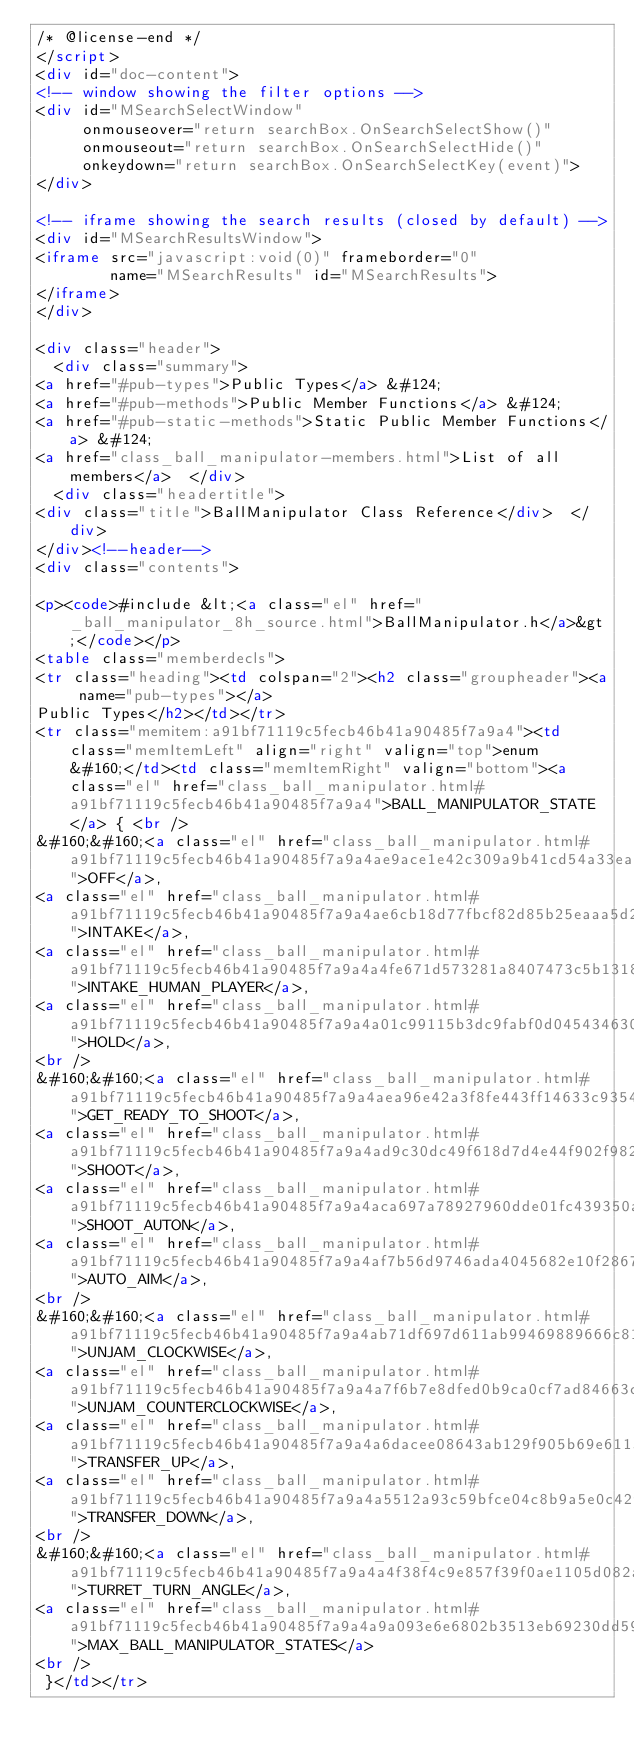<code> <loc_0><loc_0><loc_500><loc_500><_HTML_>/* @license-end */
</script>
<div id="doc-content">
<!-- window showing the filter options -->
<div id="MSearchSelectWindow"
     onmouseover="return searchBox.OnSearchSelectShow()"
     onmouseout="return searchBox.OnSearchSelectHide()"
     onkeydown="return searchBox.OnSearchSelectKey(event)">
</div>

<!-- iframe showing the search results (closed by default) -->
<div id="MSearchResultsWindow">
<iframe src="javascript:void(0)" frameborder="0" 
        name="MSearchResults" id="MSearchResults">
</iframe>
</div>

<div class="header">
  <div class="summary">
<a href="#pub-types">Public Types</a> &#124;
<a href="#pub-methods">Public Member Functions</a> &#124;
<a href="#pub-static-methods">Static Public Member Functions</a> &#124;
<a href="class_ball_manipulator-members.html">List of all members</a>  </div>
  <div class="headertitle">
<div class="title">BallManipulator Class Reference</div>  </div>
</div><!--header-->
<div class="contents">

<p><code>#include &lt;<a class="el" href="_ball_manipulator_8h_source.html">BallManipulator.h</a>&gt;</code></p>
<table class="memberdecls">
<tr class="heading"><td colspan="2"><h2 class="groupheader"><a name="pub-types"></a>
Public Types</h2></td></tr>
<tr class="memitem:a91bf71119c5fecb46b41a90485f7a9a4"><td class="memItemLeft" align="right" valign="top">enum &#160;</td><td class="memItemRight" valign="bottom"><a class="el" href="class_ball_manipulator.html#a91bf71119c5fecb46b41a90485f7a9a4">BALL_MANIPULATOR_STATE</a> { <br />
&#160;&#160;<a class="el" href="class_ball_manipulator.html#a91bf71119c5fecb46b41a90485f7a9a4ae9ace1e42c309a9b41cd54a33eac40f3">OFF</a>, 
<a class="el" href="class_ball_manipulator.html#a91bf71119c5fecb46b41a90485f7a9a4ae6cb18d77fbcf82d85b25eaaa5d25b24">INTAKE</a>, 
<a class="el" href="class_ball_manipulator.html#a91bf71119c5fecb46b41a90485f7a9a4a4fe671d573281a8407473c5b13187199">INTAKE_HUMAN_PLAYER</a>, 
<a class="el" href="class_ball_manipulator.html#a91bf71119c5fecb46b41a90485f7a9a4a01c99115b3dc9fabf0d04543463096d1">HOLD</a>, 
<br />
&#160;&#160;<a class="el" href="class_ball_manipulator.html#a91bf71119c5fecb46b41a90485f7a9a4aea96e42a3f8fe443ff14633c93543d16">GET_READY_TO_SHOOT</a>, 
<a class="el" href="class_ball_manipulator.html#a91bf71119c5fecb46b41a90485f7a9a4ad9c30dc49f618d7d4e44f902f9829ddb">SHOOT</a>, 
<a class="el" href="class_ball_manipulator.html#a91bf71119c5fecb46b41a90485f7a9a4aca697a78927960dde01fc439350ae747">SHOOT_AUTON</a>, 
<a class="el" href="class_ball_manipulator.html#a91bf71119c5fecb46b41a90485f7a9a4af7b56d9746ada4045682e10f28673676">AUTO_AIM</a>, 
<br />
&#160;&#160;<a class="el" href="class_ball_manipulator.html#a91bf71119c5fecb46b41a90485f7a9a4ab71df697d611ab99469889666c8175dc">UNJAM_CLOCKWISE</a>, 
<a class="el" href="class_ball_manipulator.html#a91bf71119c5fecb46b41a90485f7a9a4a7f6b7e8dfed0b9ca0cf7ad84663c4d60">UNJAM_COUNTERCLOCKWISE</a>, 
<a class="el" href="class_ball_manipulator.html#a91bf71119c5fecb46b41a90485f7a9a4a6dacee08643ab129f905b69e611531f2">TRANSFER_UP</a>, 
<a class="el" href="class_ball_manipulator.html#a91bf71119c5fecb46b41a90485f7a9a4a5512a93c59bfce04c8b9a5e0c42fc395">TRANSFER_DOWN</a>, 
<br />
&#160;&#160;<a class="el" href="class_ball_manipulator.html#a91bf71119c5fecb46b41a90485f7a9a4a4f38f4c9e857f39f0ae1105d082abd0f">TURRET_TURN_ANGLE</a>, 
<a class="el" href="class_ball_manipulator.html#a91bf71119c5fecb46b41a90485f7a9a4a9a093e6e6802b3513eb69230dd590167">MAX_BALL_MANIPULATOR_STATES</a>
<br />
 }</td></tr></code> 